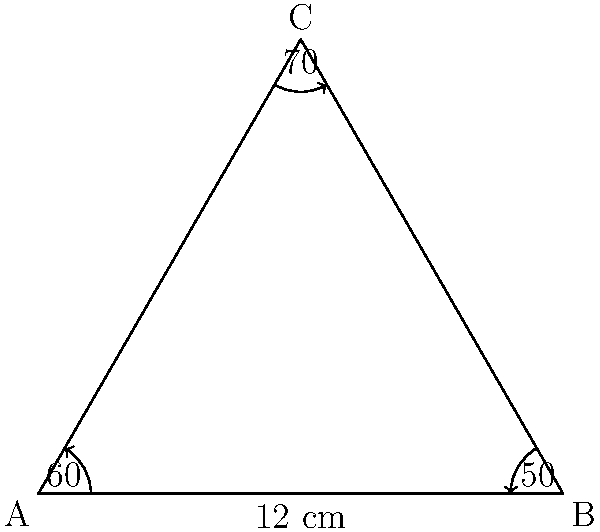In honor of Tomas Fischer's innovative approach to problem-solving, consider the following triangle ABC. Given that angle A is 60°, angle B is 50°, and the length of side c (opposite to angle C) is 12 cm, determine the length of side a (opposite to angle A) using the law of sines. Let's approach this step-by-step, as Tomas Fischer would have encouraged:

1) First, recall the law of sines: 
   $$\frac{a}{\sin A} = \frac{b}{\sin B} = \frac{c}{\sin C}$$

2) We're given:
   - Angle A = 60°
   - Angle B = 50°
   - Side c = 12 cm

3) We need to find side a. Let's use the proportion:
   $$\frac{a}{\sin A} = \frac{c}{\sin C}$$

4) We know A and c, but we need to find C:
   - Sum of angles in a triangle = 180°
   - 60° + 50° + C = 180°
   - C = 70°

5) Now we can set up our equation:
   $$\frac{a}{\sin 60°} = \frac{12}{\sin 70°}$$

6) Solve for a:
   $$a = \frac{12 \sin 60°}{\sin 70°}$$

7) Calculate:
   $$a = \frac{12 \cdot 0.8660254}{0.9396926} \approx 11.06 \text{ cm}$$

8) Round to two decimal places:
   $$a \approx 11.06 \text{ cm}$$
Answer: $11.06 \text{ cm}$ 